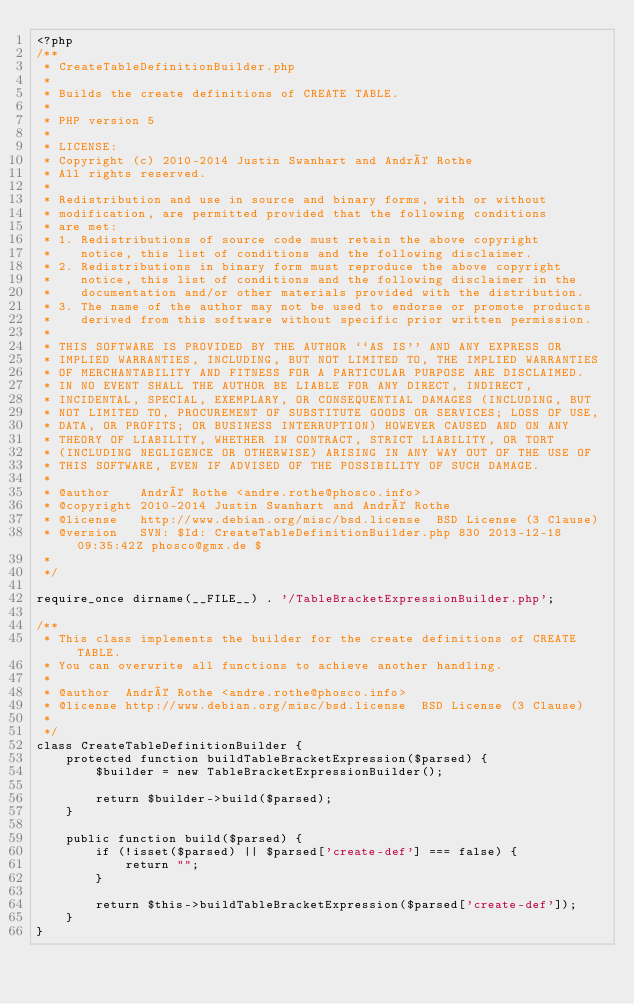Convert code to text. <code><loc_0><loc_0><loc_500><loc_500><_PHP_><?php
/**
 * CreateTableDefinitionBuilder.php
 *
 * Builds the create definitions of CREATE TABLE.
 *
 * PHP version 5
 *
 * LICENSE:
 * Copyright (c) 2010-2014 Justin Swanhart and André Rothe
 * All rights reserved.
 *
 * Redistribution and use in source and binary forms, with or without
 * modification, are permitted provided that the following conditions
 * are met:
 * 1. Redistributions of source code must retain the above copyright
 *    notice, this list of conditions and the following disclaimer.
 * 2. Redistributions in binary form must reproduce the above copyright
 *    notice, this list of conditions and the following disclaimer in the
 *    documentation and/or other materials provided with the distribution.
 * 3. The name of the author may not be used to endorse or promote products
 *    derived from this software without specific prior written permission.
 *
 * THIS SOFTWARE IS PROVIDED BY THE AUTHOR ``AS IS'' AND ANY EXPRESS OR
 * IMPLIED WARRANTIES, INCLUDING, BUT NOT LIMITED TO, THE IMPLIED WARRANTIES
 * OF MERCHANTABILITY AND FITNESS FOR A PARTICULAR PURPOSE ARE DISCLAIMED.
 * IN NO EVENT SHALL THE AUTHOR BE LIABLE FOR ANY DIRECT, INDIRECT,
 * INCIDENTAL, SPECIAL, EXEMPLARY, OR CONSEQUENTIAL DAMAGES (INCLUDING, BUT
 * NOT LIMITED TO, PROCUREMENT OF SUBSTITUTE GOODS OR SERVICES; LOSS OF USE,
 * DATA, OR PROFITS; OR BUSINESS INTERRUPTION) HOWEVER CAUSED AND ON ANY
 * THEORY OF LIABILITY, WHETHER IN CONTRACT, STRICT LIABILITY, OR TORT
 * (INCLUDING NEGLIGENCE OR OTHERWISE) ARISING IN ANY WAY OUT OF THE USE OF
 * THIS SOFTWARE, EVEN IF ADVISED OF THE POSSIBILITY OF SUCH DAMAGE.
 * 
 * @author    André Rothe <andre.rothe@phosco.info>
 * @copyright 2010-2014 Justin Swanhart and André Rothe
 * @license   http://www.debian.org/misc/bsd.license  BSD License (3 Clause)
 * @version   SVN: $Id: CreateTableDefinitionBuilder.php 830 2013-12-18 09:35:42Z phosco@gmx.de $
 * 
 */

require_once dirname(__FILE__) . '/TableBracketExpressionBuilder.php';

/**
 * This class implements the builder for the create definitions of CREATE TABLE. 
 * You can overwrite all functions to achieve another handling.
 *
 * @author  André Rothe <andre.rothe@phosco.info>
 * @license http://www.debian.org/misc/bsd.license  BSD License (3 Clause)
 *  
 */
class CreateTableDefinitionBuilder {
    protected function buildTableBracketExpression($parsed) {
        $builder = new TableBracketExpressionBuilder();

        return $builder->build($parsed);
    }

    public function build($parsed) {
        if (!isset($parsed) || $parsed['create-def'] === false) {
            return "";
        }

        return $this->buildTableBracketExpression($parsed['create-def']);
    }
}
</code> 